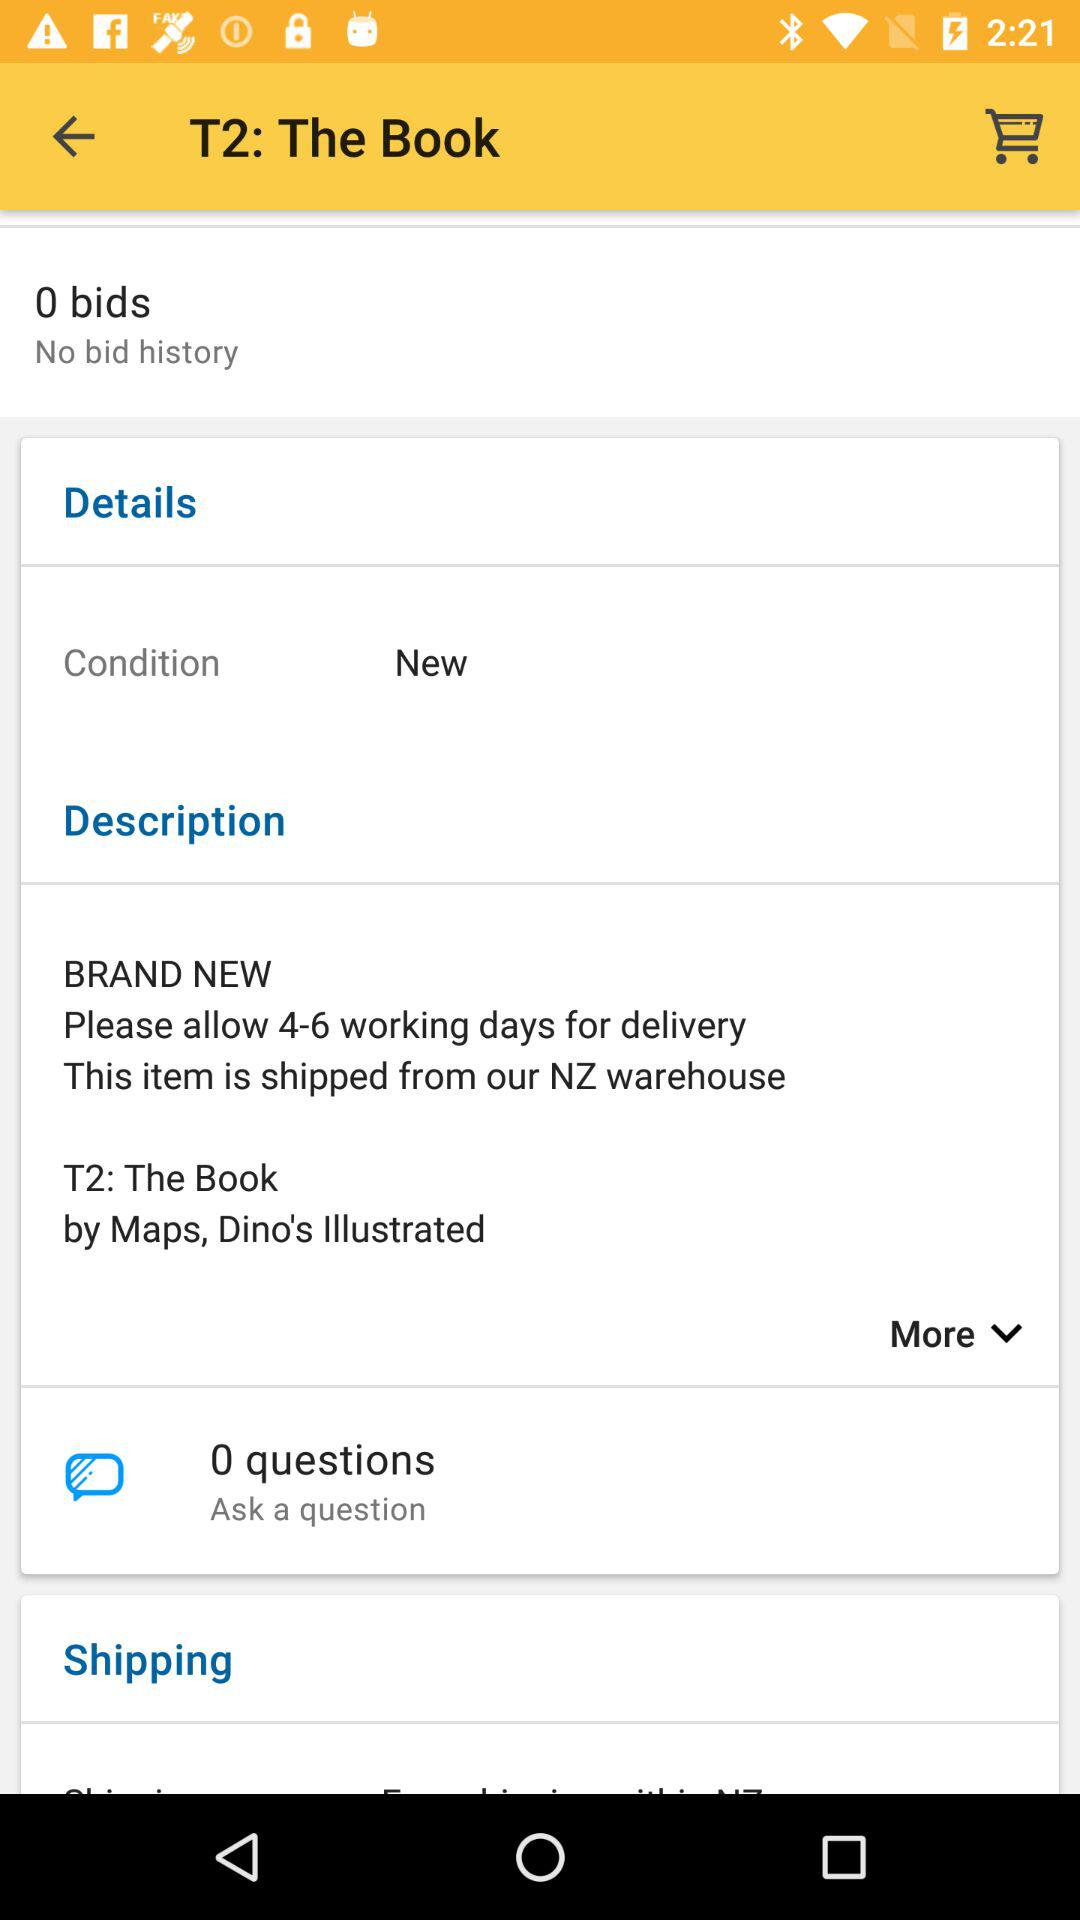Who is the author of the T2 book? The author is "Maps". 